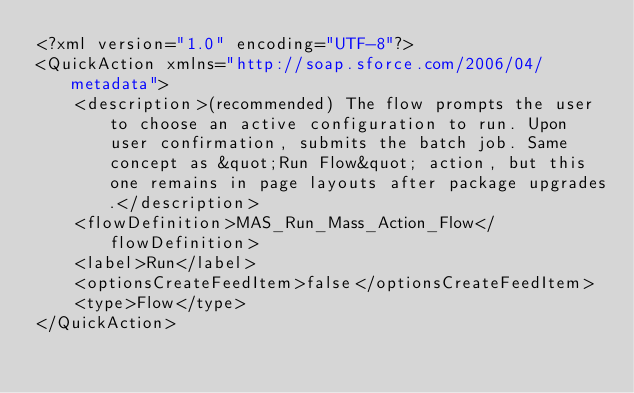Convert code to text. <code><loc_0><loc_0><loc_500><loc_500><_XML_><?xml version="1.0" encoding="UTF-8"?>
<QuickAction xmlns="http://soap.sforce.com/2006/04/metadata">
    <description>(recommended) The flow prompts the user to choose an active configuration to run. Upon user confirmation, submits the batch job. Same concept as &quot;Run Flow&quot; action, but this one remains in page layouts after package upgrades.</description>
    <flowDefinition>MAS_Run_Mass_Action_Flow</flowDefinition>
    <label>Run</label>
    <optionsCreateFeedItem>false</optionsCreateFeedItem>
    <type>Flow</type>
</QuickAction>
</code> 